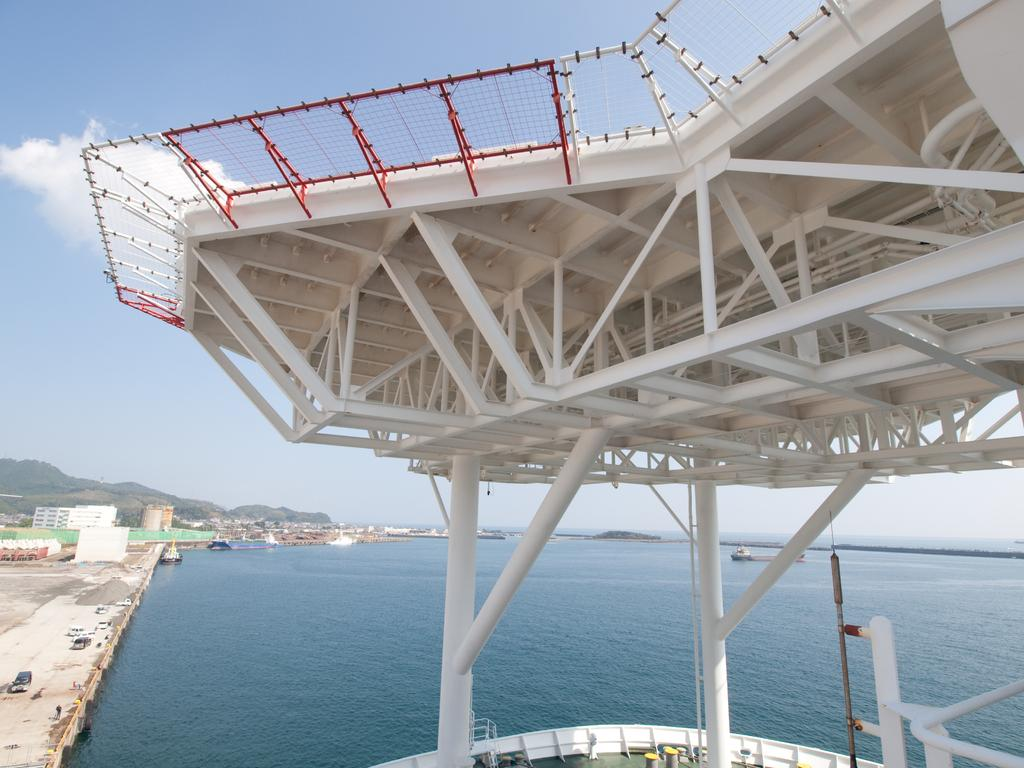What type of surface is visible in the image? There is a boat deck in the image. What objects can be seen on the boat deck? There are poles visible on the boat deck. What can be seen in the background of the image? There is water, boats, mountains, and sky visible in the background of the image. Are there any unidentified objects in the background of the image? Yes, there are some unspecified objects in the background of the image. How does the boat deck compare to the smell of a rose in the image? There is no reference to a rose or any smell in the image, so it is not possible to make a comparison. 